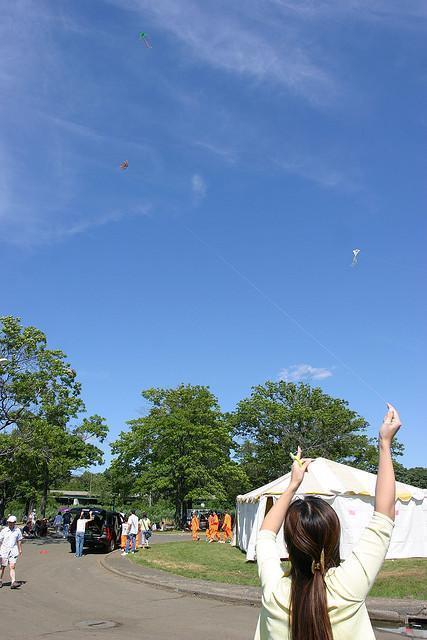What makes this a good day for flying kites?
Indicate the correct choice and explain in the format: 'Answer: answer
Rationale: rationale.'
Options: Humid, cold, cloudy, clear skies. Answer: clear skies.
Rationale: There are no clouds, making it easy to see the kite. 